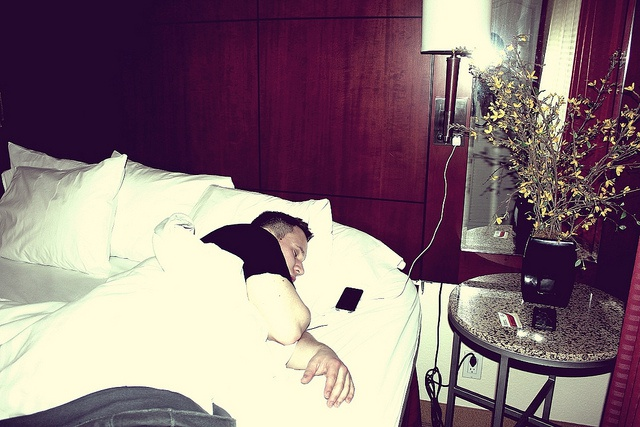Describe the objects in this image and their specific colors. I can see bed in navy, lightyellow, darkgray, and beige tones, people in navy, lightyellow, gray, and tan tones, potted plant in navy, black, gray, purple, and darkgray tones, vase in navy, gray, black, and white tones, and cell phone in navy, darkgray, ivory, and gray tones in this image. 